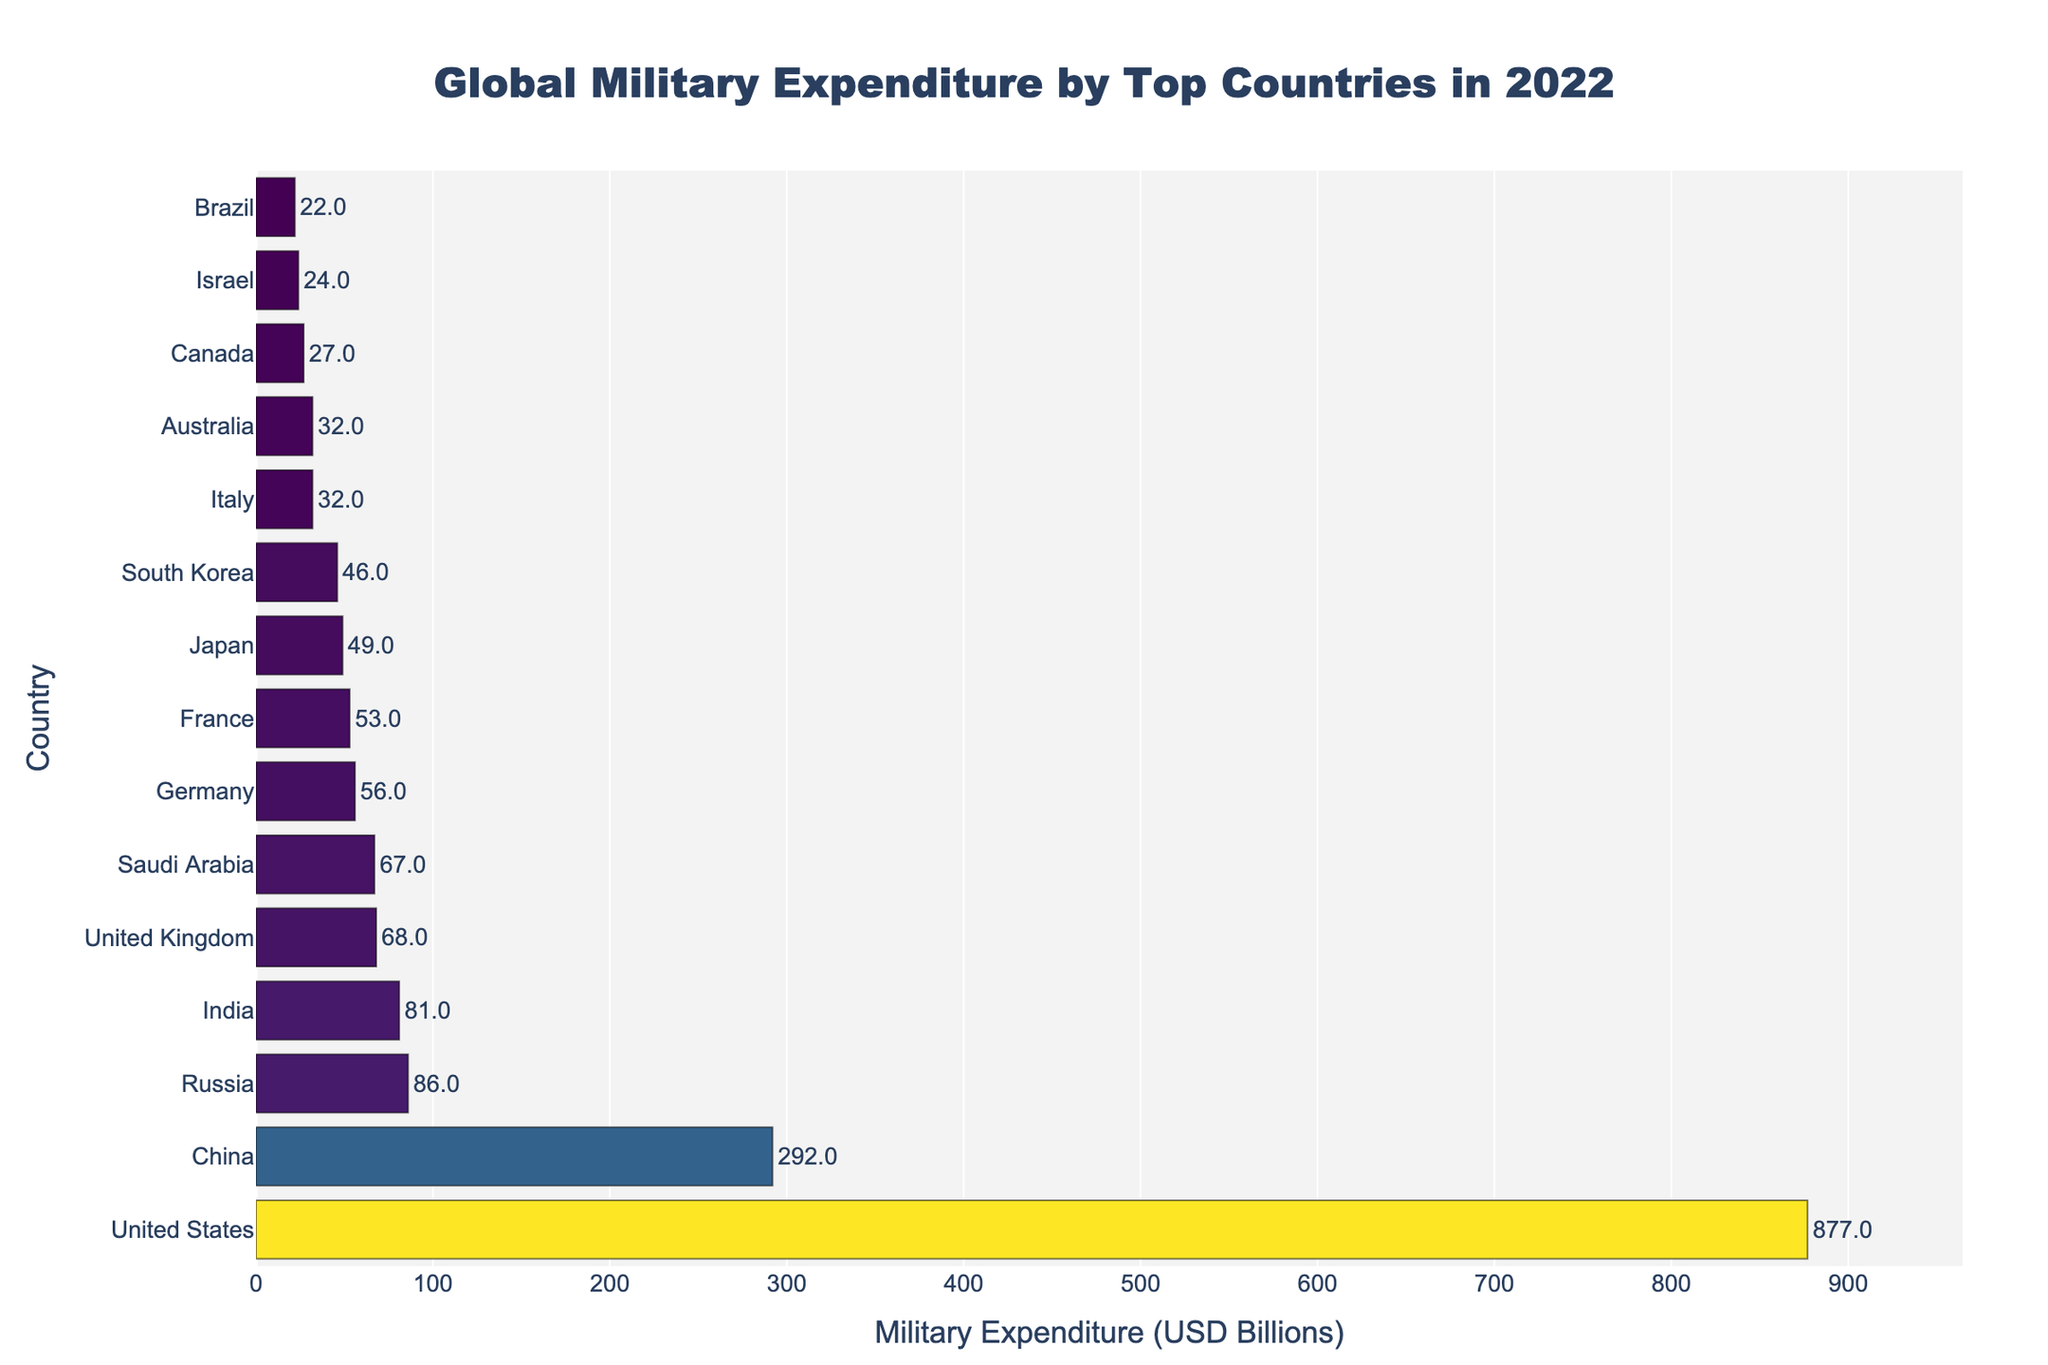Which country has the highest military expenditure? The graph shows the bar representing the military expenditure for each country, with the highest bar belonging to the United States.
Answer: United States What is the difference in military expenditure between China and Russia? From the graph, China has a military expenditure of 292 billion USD, while Russia has 86 billion USD. Subtracting Russia's expenditure from China's gives 292 - 86 = 206 billion USD.
Answer: 206 billion USD Which country ranks third in military expenditure? The third highest bar on the graph corresponds to Russia.
Answer: Russia How much more does the United States spend compared to India? The United States spends 877 billion USD, and India spends 81 billion USD. The difference is 877 - 81 = 796 billion USD.
Answer: 796 billion USD How many countries have military expenditures exceeding 50 billion USD? By examining the graph, we can see the bars for the United States, China, Russia, India, United Kingdom, Saudi Arabia, Germany, France, and Japan exceed 50 billion USD, making a total of 9 countries.
Answer: 9 countries Which country spends exactly 46 billion USD on military expenditure? From the graph, the only country with a bar representing 46 billion USD in military expenditure is South Korea.
Answer: South Korea What is the combined military expenditure of the United Kingdom and Saudi Arabia? The United Kingdom spends 68 billion USD, and Saudi Arabia spends 67 billion USD. Adding them together gives 68 + 67 = 135 billion USD.
Answer: 135 billion USD What is the average military expenditure of the top 5 countries? The top 5 countries are the United States, China, Russia, India, and the United Kingdom. Their expenditures are 877 + 292 + 86 + 81 + 68 = 1404 billion USD. Dividing by 5, the average is 1404 / 5 = 280.8 billion USD.
Answer: 280.8 billion USD Which country has a military expenditure greater than Canada but less than Japan? By looking at the graph, South Korea, with 46 billion USD, fits this criterion since it is above Canada's 27 billion USD and below Japan's 49 billion USD.
Answer: South Korea What is the sum of the military expenditures of the bottom three countries in the list? The bottom three countries are Brazil, Israel, and Canada, with expenditures of 22, 24, and 27 billion USD respectively. Adding these together gives 22 + 24 + 27 = 73 billion USD.
Answer: 73 billion USD 